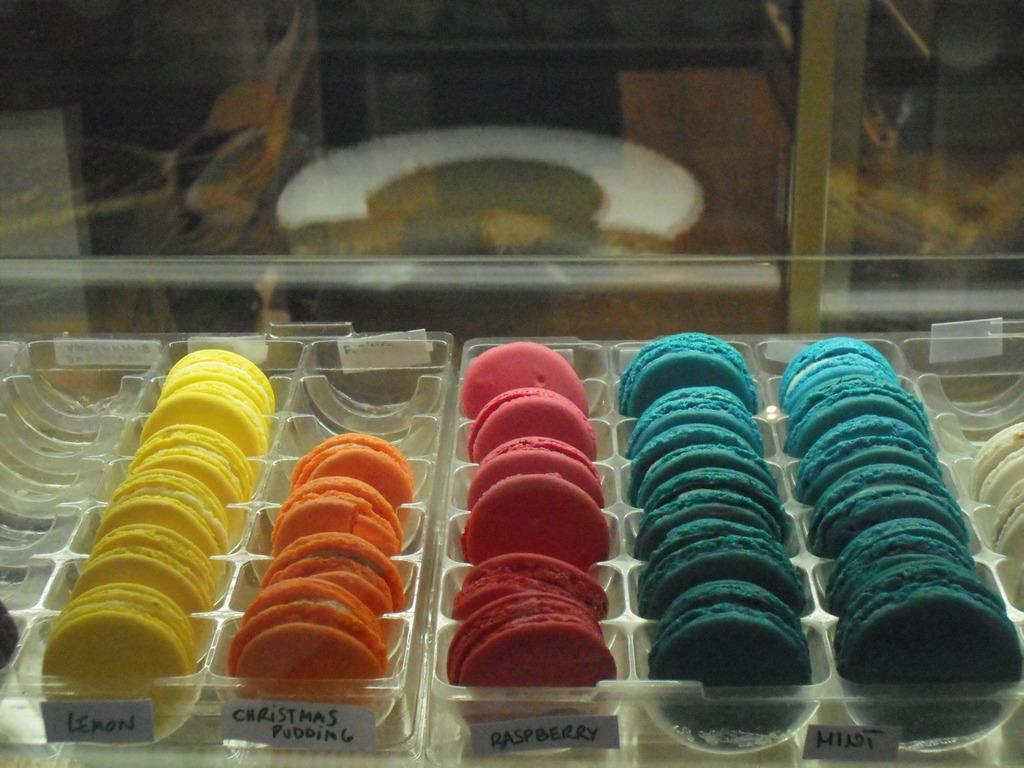<image>
Present a compact description of the photo's key features. One of the rows of cookies is Lemon flavored 